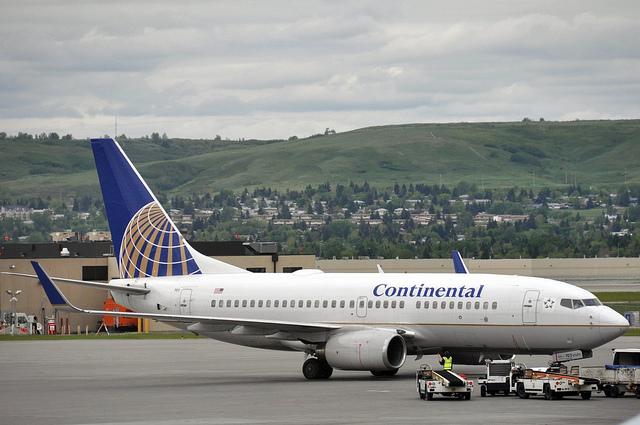What type of airline is this?
Answer briefly. Continental. How was this photo taken?
Answer briefly. With camera. Is the plane landing?
Write a very short answer. No. What is the airplane company that is flying this jet?
Be succinct. Continental. Is the land in the background flat?
Answer briefly. No. 